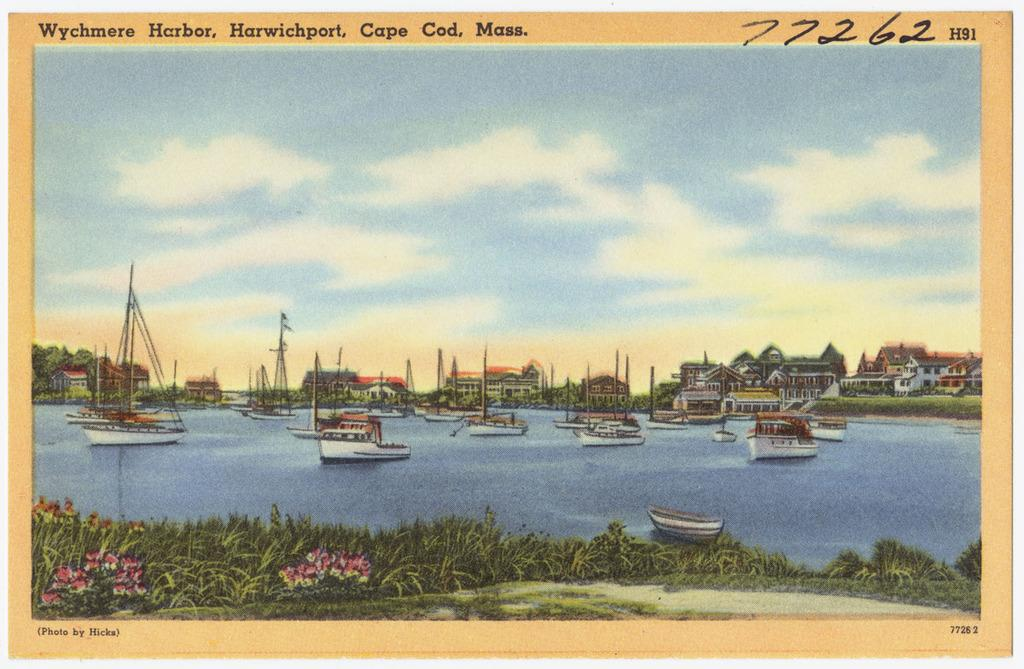<image>
Write a terse but informative summary of the picture. A postcard of sailboats titled Wychmere Harbor, Harwichport, Cape Cod, Mass. 